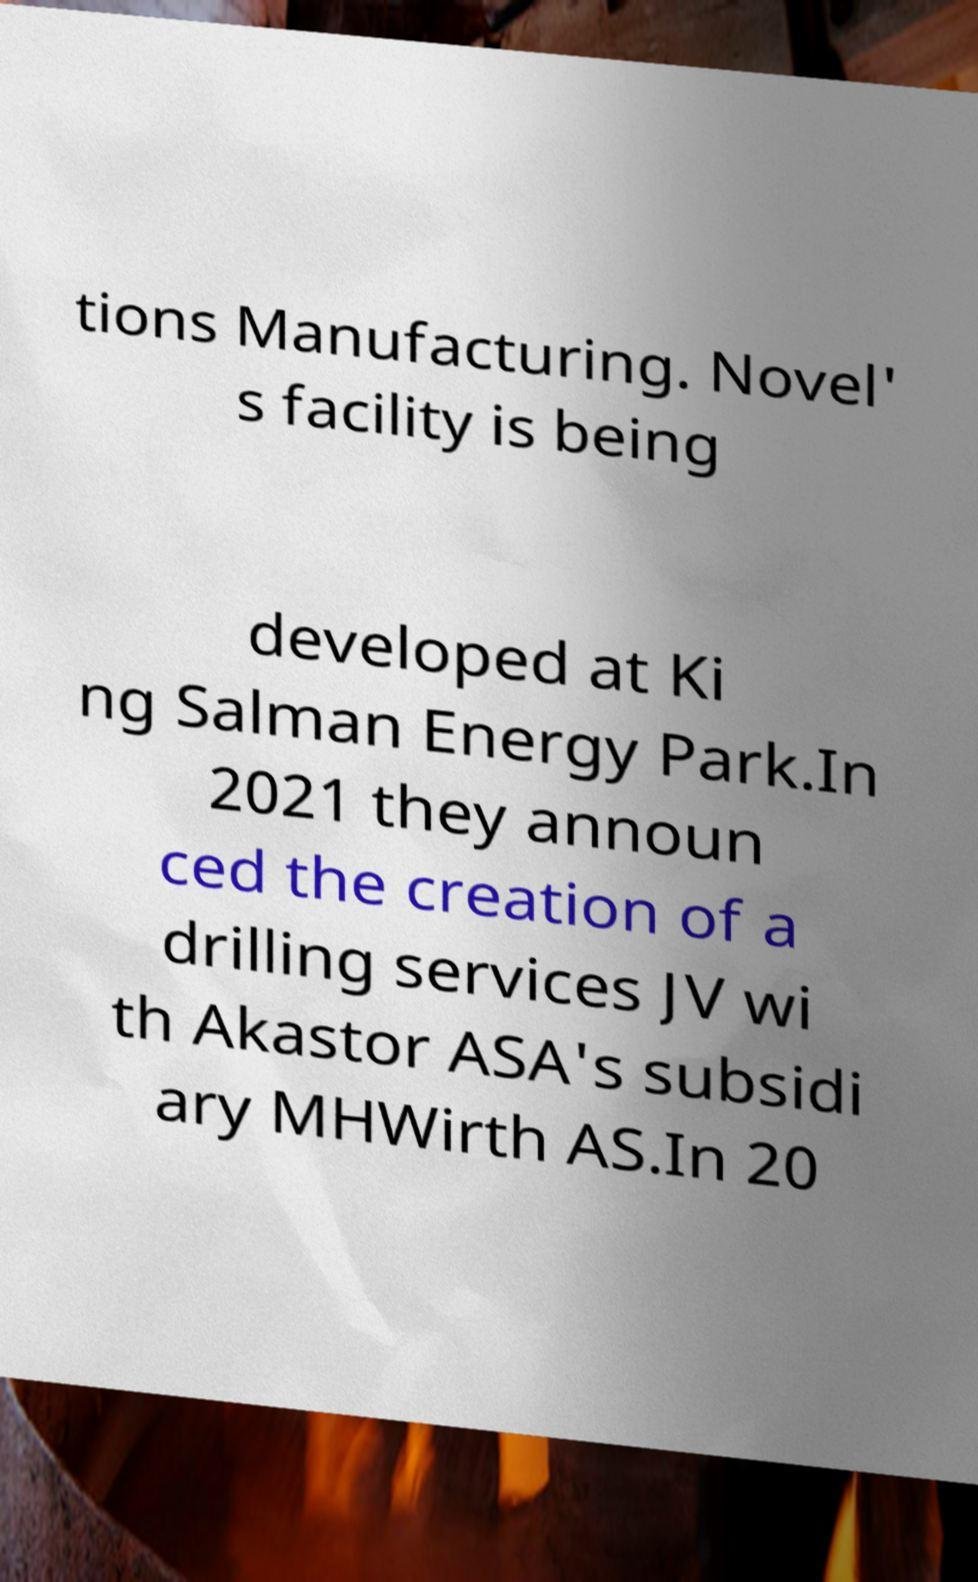For documentation purposes, I need the text within this image transcribed. Could you provide that? tions Manufacturing. Novel' s facility is being developed at Ki ng Salman Energy Park.In 2021 they announ ced the creation of a drilling services JV wi th Akastor ASA's subsidi ary MHWirth AS.In 20 